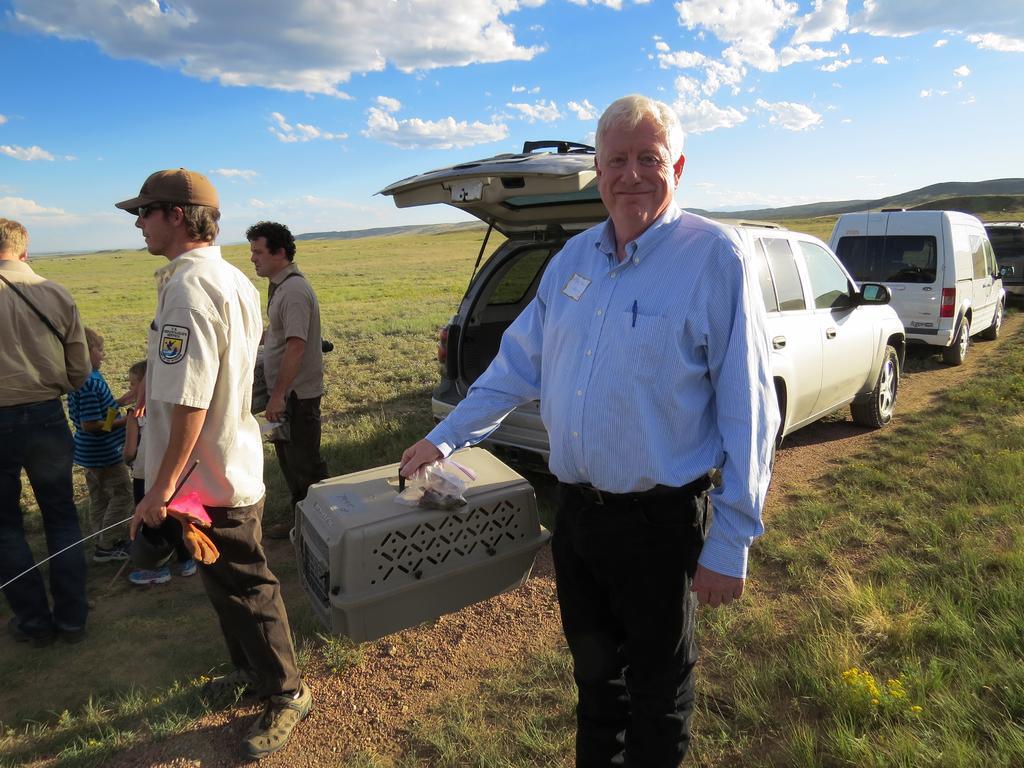Please provide a concise description of this image. In this picture we can observe some people standing. We can observe a man holding a grey color box and smiling. Behind them there are some cars parked on the ground. There is some grass on the ground. In the background there is a sky with some clouds. 